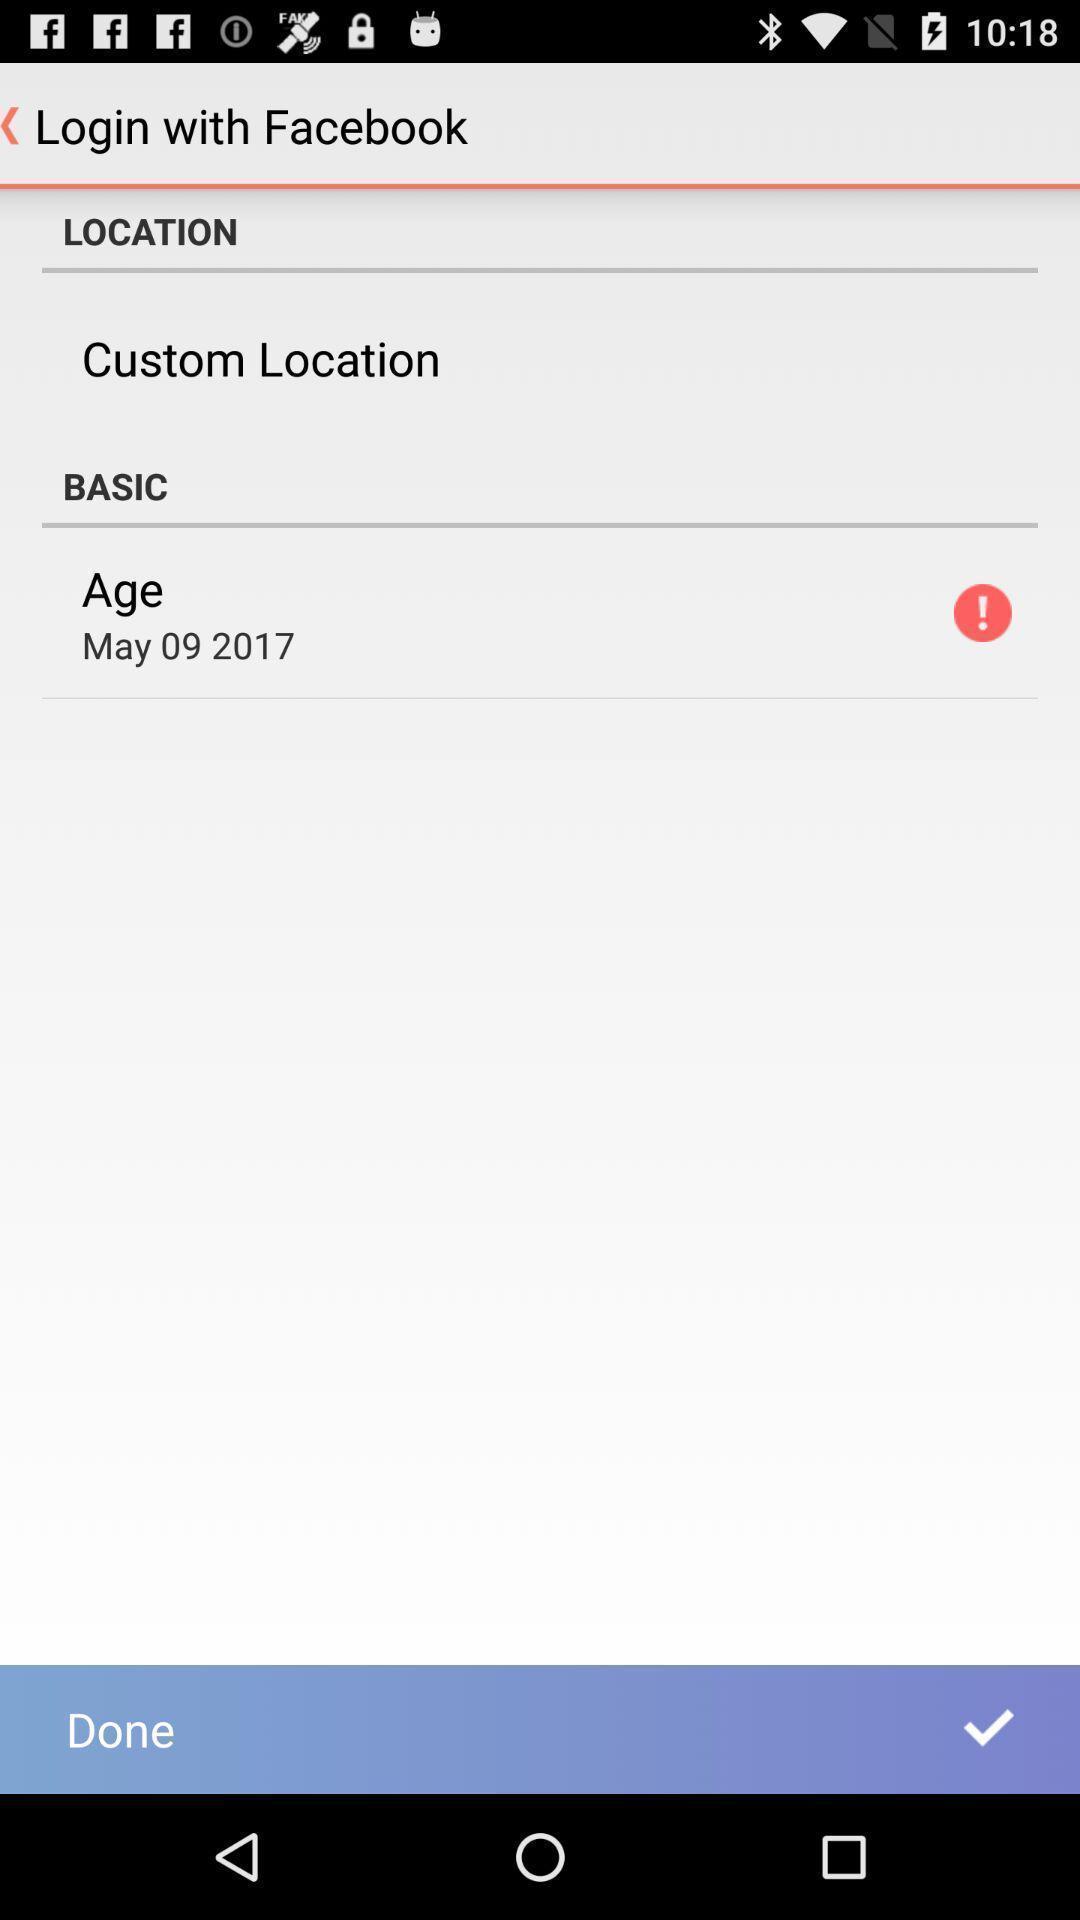Give me a summary of this screen capture. Page displaying signing in information about an application. 